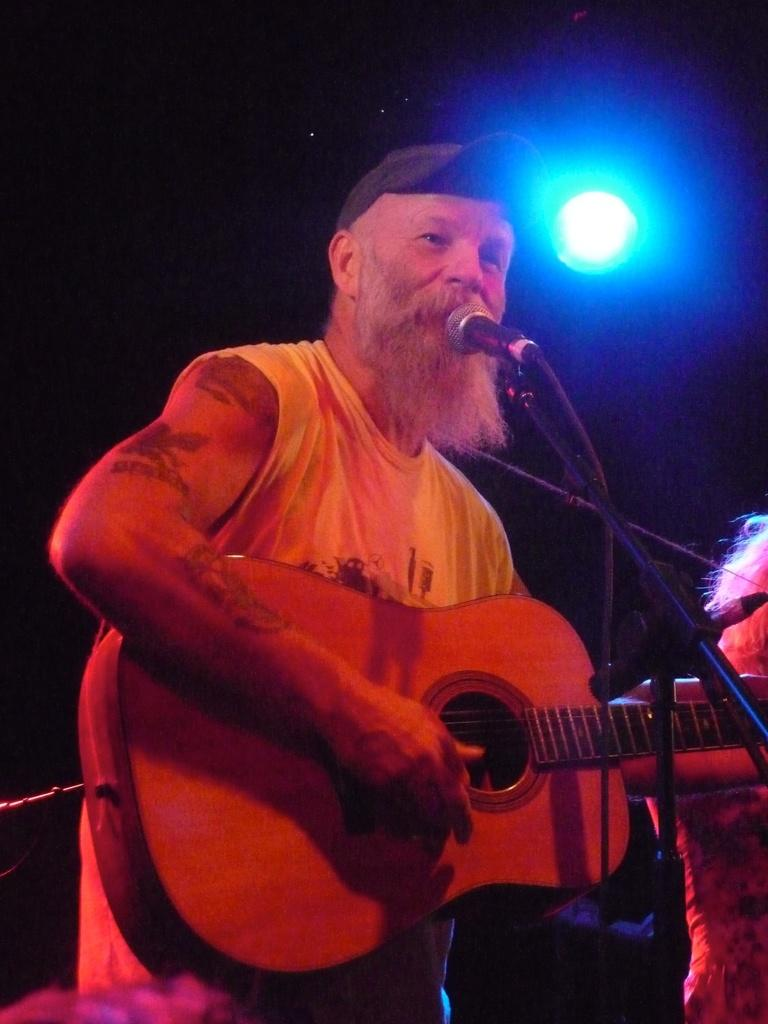What is the main activity of the person in the image? The person in the image is standing and playing guitar. What object is in front of the person playing guitar? There is a microphone in the front of the image. Can you describe the presence of another person in the image? Yes, there is another person present at the back of the image. What can be seen at the top of the image? There is a light visible at the top of the image. What type of drink is being served to the audience in the image? There is no drink being served to the audience in the image; it only shows a person playing guitar and a microphone. 